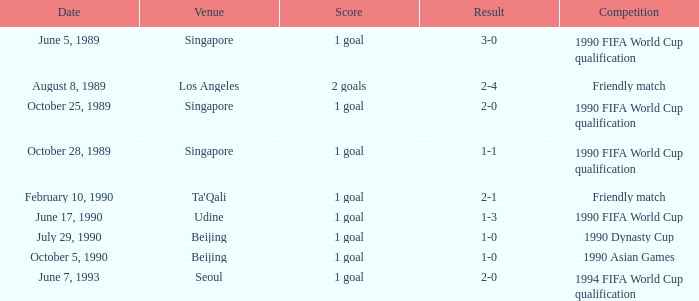What is the score of the match on July 29, 1990? 1 goal. 